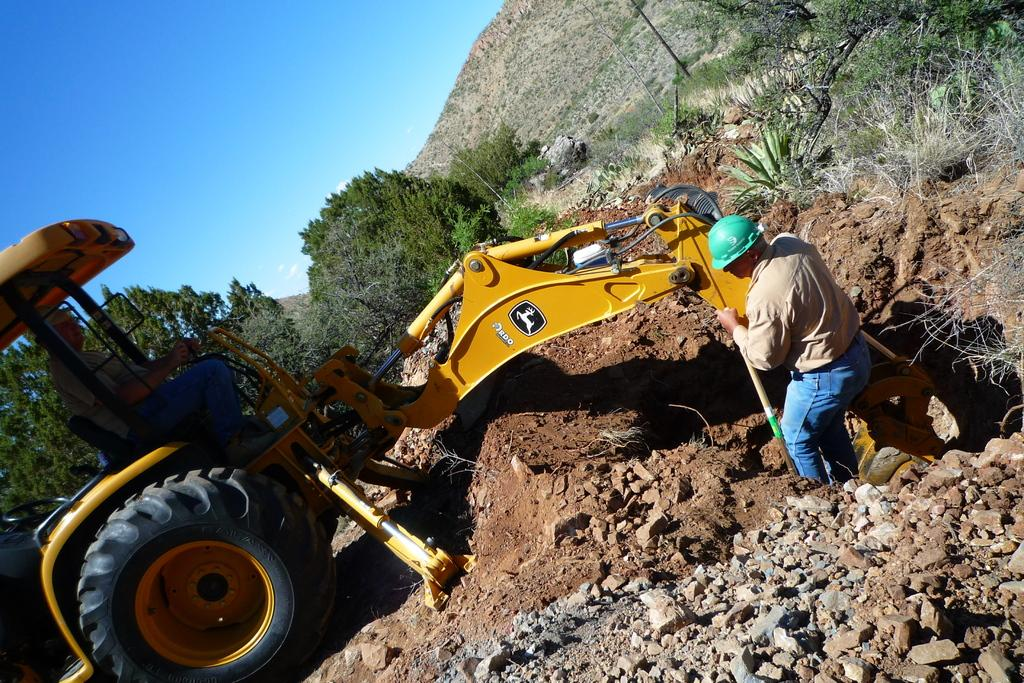What is the person in the image doing? There is a person sitting in a vehicle in the image. What is the other person holding in the image? The other person is holding a stick in the image. What type of terrain can be seen in the image? There are rocks, mud, plants, and trees visible in the image. What is the background of the image? There is a mountain and the sky visible in the image. What is the value of the root in the image? There is no root present in the image. What is the purpose of the person holding the stick in the image? The purpose of the person holding the stick cannot be determined from the image alone. 